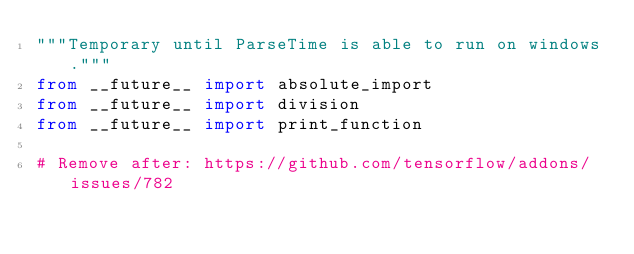<code> <loc_0><loc_0><loc_500><loc_500><_Python_>"""Temporary until ParseTime is able to run on windows."""
from __future__ import absolute_import
from __future__ import division
from __future__ import print_function

# Remove after: https://github.com/tensorflow/addons/issues/782
</code> 